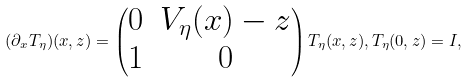Convert formula to latex. <formula><loc_0><loc_0><loc_500><loc_500>( \partial _ { x } T _ { \eta } ) ( x , z ) = \begin{pmatrix} 0 & V _ { \eta } ( x ) - z \\ 1 & 0 \end{pmatrix} T _ { \eta } ( x , z ) , T _ { \eta } ( 0 , z ) = I ,</formula> 